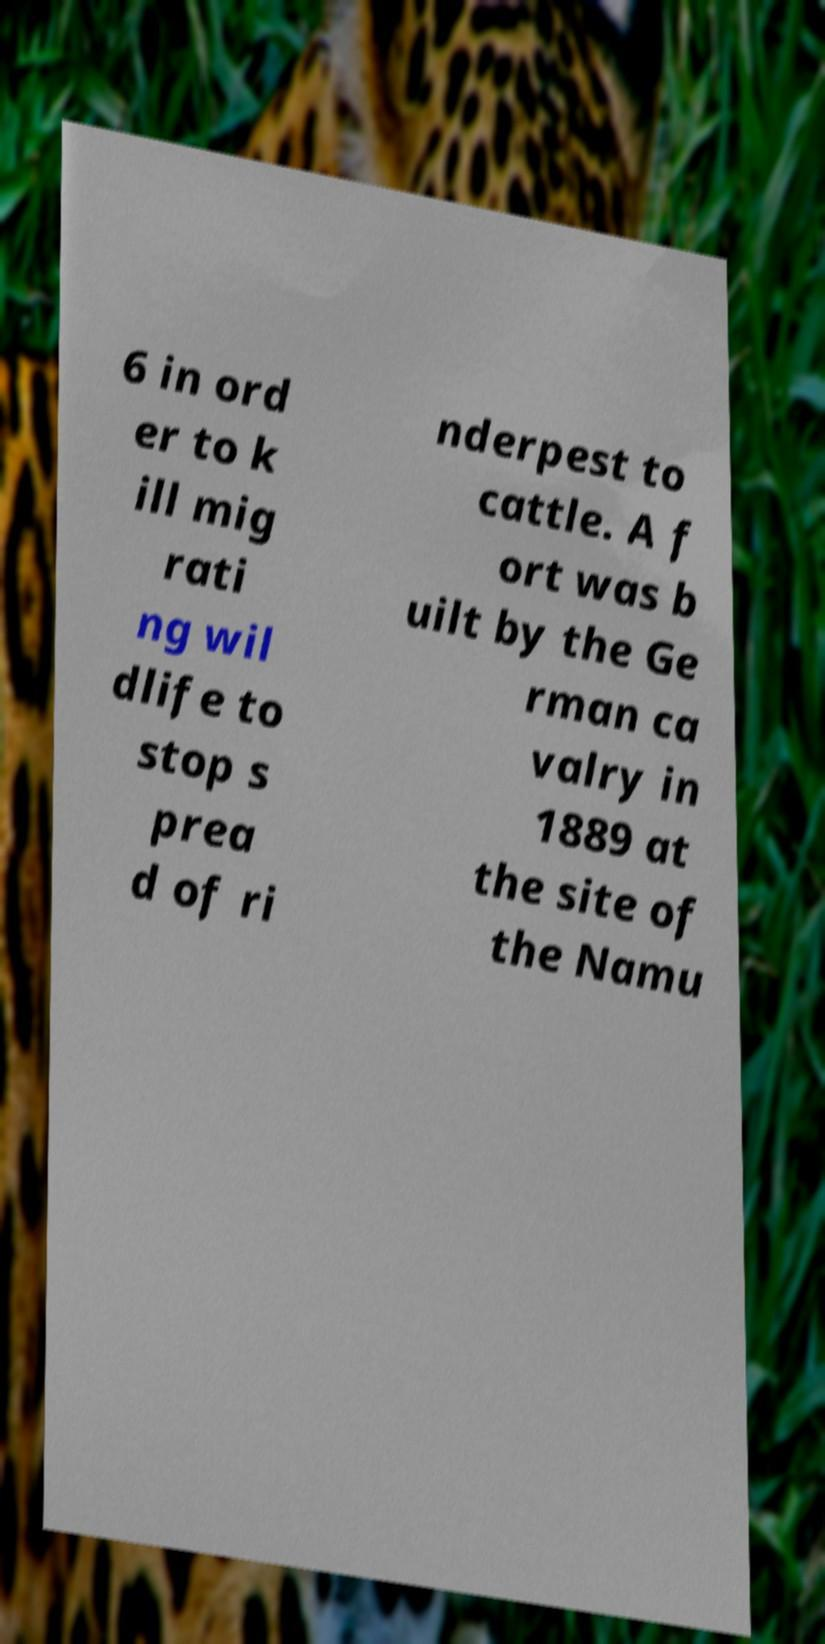Can you read and provide the text displayed in the image?This photo seems to have some interesting text. Can you extract and type it out for me? 6 in ord er to k ill mig rati ng wil dlife to stop s prea d of ri nderpest to cattle. A f ort was b uilt by the Ge rman ca valry in 1889 at the site of the Namu 